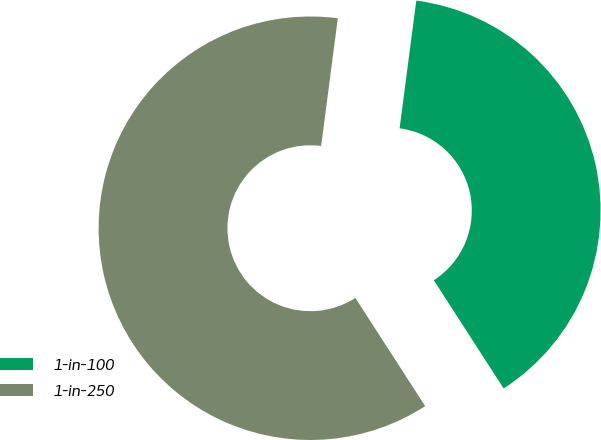<chart> <loc_0><loc_0><loc_500><loc_500><pie_chart><fcel>1-in-100<fcel>1-in-250<nl><fcel>38.81%<fcel>61.19%<nl></chart> 